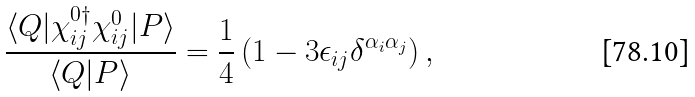<formula> <loc_0><loc_0><loc_500><loc_500>\frac { \langle Q | \chi ^ { 0 \dagger } _ { i j } \chi ^ { 0 } _ { i j } | P \rangle } { \langle Q | P \rangle } = \frac { 1 } { 4 } \left ( 1 - 3 \epsilon _ { i j } \delta ^ { \alpha _ { i } \alpha _ { j } } \right ) ,</formula> 